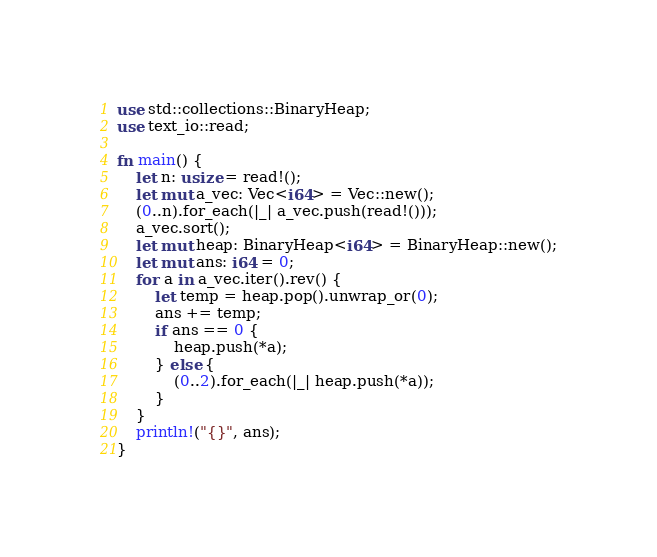<code> <loc_0><loc_0><loc_500><loc_500><_Rust_>use std::collections::BinaryHeap;
use text_io::read;

fn main() {
    let n: usize = read!();
    let mut a_vec: Vec<i64> = Vec::new();
    (0..n).for_each(|_| a_vec.push(read!()));
    a_vec.sort();
    let mut heap: BinaryHeap<i64> = BinaryHeap::new();
    let mut ans: i64 = 0;
    for a in a_vec.iter().rev() {
        let temp = heap.pop().unwrap_or(0);
        ans += temp;
        if ans == 0 {
            heap.push(*a);
        } else {
            (0..2).for_each(|_| heap.push(*a));
        }
    }
    println!("{}", ans);
}
</code> 